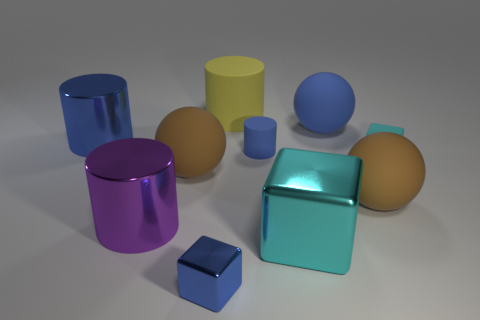How many yellow objects are the same material as the small cylinder? Upon examining the image, there is one yellow cylinder that appears to have the same reflective material as the small cylinder. 